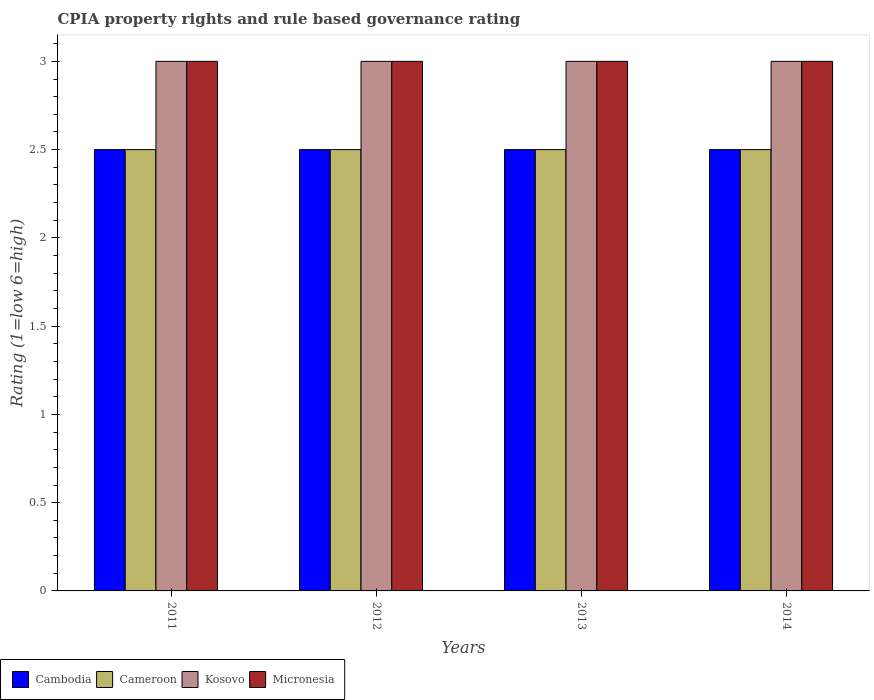How many different coloured bars are there?
Your response must be concise. 4. How many groups of bars are there?
Keep it short and to the point. 4. Are the number of bars on each tick of the X-axis equal?
Provide a short and direct response. Yes. What is the label of the 3rd group of bars from the left?
Keep it short and to the point. 2013. In how many cases, is the number of bars for a given year not equal to the number of legend labels?
Offer a terse response. 0. What is the CPIA rating in Cameroon in 2014?
Keep it short and to the point. 2.5. In which year was the CPIA rating in Cameroon minimum?
Your answer should be compact. 2011. What is the total CPIA rating in Cambodia in the graph?
Keep it short and to the point. 10. What is the difference between the CPIA rating in Cameroon in 2014 and the CPIA rating in Kosovo in 2013?
Ensure brevity in your answer.  -0.5. In how many years, is the CPIA rating in Kosovo greater than 1.4?
Offer a terse response. 4. What does the 2nd bar from the left in 2011 represents?
Provide a succinct answer. Cameroon. What does the 4th bar from the right in 2013 represents?
Provide a succinct answer. Cambodia. Is it the case that in every year, the sum of the CPIA rating in Micronesia and CPIA rating in Cameroon is greater than the CPIA rating in Kosovo?
Your answer should be very brief. Yes. How many bars are there?
Offer a very short reply. 16. Are all the bars in the graph horizontal?
Keep it short and to the point. No. How many years are there in the graph?
Provide a succinct answer. 4. What is the difference between two consecutive major ticks on the Y-axis?
Make the answer very short. 0.5. Does the graph contain any zero values?
Keep it short and to the point. No. How many legend labels are there?
Provide a succinct answer. 4. How are the legend labels stacked?
Provide a succinct answer. Horizontal. What is the title of the graph?
Make the answer very short. CPIA property rights and rule based governance rating. What is the label or title of the X-axis?
Keep it short and to the point. Years. What is the Rating (1=low 6=high) in Cambodia in 2011?
Your answer should be compact. 2.5. What is the Rating (1=low 6=high) in Kosovo in 2011?
Provide a succinct answer. 3. What is the Rating (1=low 6=high) of Kosovo in 2012?
Your answer should be very brief. 3. What is the Rating (1=low 6=high) in Micronesia in 2012?
Your response must be concise. 3. What is the Rating (1=low 6=high) in Cambodia in 2013?
Make the answer very short. 2.5. What is the Rating (1=low 6=high) of Cameroon in 2013?
Give a very brief answer. 2.5. What is the Rating (1=low 6=high) of Kosovo in 2013?
Make the answer very short. 3. What is the Rating (1=low 6=high) in Cameroon in 2014?
Offer a terse response. 2.5. What is the Rating (1=low 6=high) of Micronesia in 2014?
Your answer should be very brief. 3. Across all years, what is the minimum Rating (1=low 6=high) of Cameroon?
Offer a very short reply. 2.5. Across all years, what is the minimum Rating (1=low 6=high) in Kosovo?
Your answer should be very brief. 3. What is the total Rating (1=low 6=high) in Cambodia in the graph?
Your response must be concise. 10. What is the total Rating (1=low 6=high) of Kosovo in the graph?
Your response must be concise. 12. What is the difference between the Rating (1=low 6=high) of Cameroon in 2011 and that in 2012?
Your answer should be compact. 0. What is the difference between the Rating (1=low 6=high) of Cameroon in 2011 and that in 2013?
Provide a succinct answer. 0. What is the difference between the Rating (1=low 6=high) of Micronesia in 2011 and that in 2013?
Your answer should be very brief. 0. What is the difference between the Rating (1=low 6=high) in Kosovo in 2011 and that in 2014?
Give a very brief answer. 0. What is the difference between the Rating (1=low 6=high) in Micronesia in 2011 and that in 2014?
Your answer should be compact. 0. What is the difference between the Rating (1=low 6=high) in Cameroon in 2012 and that in 2013?
Keep it short and to the point. 0. What is the difference between the Rating (1=low 6=high) in Kosovo in 2012 and that in 2013?
Provide a succinct answer. 0. What is the difference between the Rating (1=low 6=high) of Cambodia in 2012 and that in 2014?
Offer a terse response. 0. What is the difference between the Rating (1=low 6=high) in Cameroon in 2012 and that in 2014?
Your response must be concise. 0. What is the difference between the Rating (1=low 6=high) of Kosovo in 2012 and that in 2014?
Provide a succinct answer. 0. What is the difference between the Rating (1=low 6=high) of Micronesia in 2012 and that in 2014?
Provide a succinct answer. 0. What is the difference between the Rating (1=low 6=high) of Kosovo in 2013 and that in 2014?
Make the answer very short. 0. What is the difference between the Rating (1=low 6=high) of Cambodia in 2011 and the Rating (1=low 6=high) of Cameroon in 2012?
Give a very brief answer. 0. What is the difference between the Rating (1=low 6=high) in Cambodia in 2011 and the Rating (1=low 6=high) in Kosovo in 2012?
Your response must be concise. -0.5. What is the difference between the Rating (1=low 6=high) in Cameroon in 2011 and the Rating (1=low 6=high) in Kosovo in 2012?
Your answer should be very brief. -0.5. What is the difference between the Rating (1=low 6=high) of Cameroon in 2011 and the Rating (1=low 6=high) of Micronesia in 2012?
Ensure brevity in your answer.  -0.5. What is the difference between the Rating (1=low 6=high) in Kosovo in 2011 and the Rating (1=low 6=high) in Micronesia in 2012?
Your response must be concise. 0. What is the difference between the Rating (1=low 6=high) of Cameroon in 2011 and the Rating (1=low 6=high) of Kosovo in 2013?
Offer a terse response. -0.5. What is the difference between the Rating (1=low 6=high) in Cameroon in 2011 and the Rating (1=low 6=high) in Micronesia in 2013?
Make the answer very short. -0.5. What is the difference between the Rating (1=low 6=high) in Cameroon in 2011 and the Rating (1=low 6=high) in Kosovo in 2014?
Offer a terse response. -0.5. What is the difference between the Rating (1=low 6=high) of Kosovo in 2011 and the Rating (1=low 6=high) of Micronesia in 2014?
Give a very brief answer. 0. What is the difference between the Rating (1=low 6=high) of Cambodia in 2012 and the Rating (1=low 6=high) of Kosovo in 2013?
Your answer should be very brief. -0.5. What is the difference between the Rating (1=low 6=high) of Cameroon in 2012 and the Rating (1=low 6=high) of Micronesia in 2013?
Make the answer very short. -0.5. What is the difference between the Rating (1=low 6=high) in Kosovo in 2012 and the Rating (1=low 6=high) in Micronesia in 2013?
Your response must be concise. 0. What is the difference between the Rating (1=low 6=high) of Cameroon in 2012 and the Rating (1=low 6=high) of Micronesia in 2014?
Make the answer very short. -0.5. What is the difference between the Rating (1=low 6=high) in Cambodia in 2013 and the Rating (1=low 6=high) in Cameroon in 2014?
Your answer should be compact. 0. What is the difference between the Rating (1=low 6=high) of Cameroon in 2013 and the Rating (1=low 6=high) of Kosovo in 2014?
Your response must be concise. -0.5. What is the difference between the Rating (1=low 6=high) in Cameroon in 2013 and the Rating (1=low 6=high) in Micronesia in 2014?
Your response must be concise. -0.5. What is the difference between the Rating (1=low 6=high) in Kosovo in 2013 and the Rating (1=low 6=high) in Micronesia in 2014?
Keep it short and to the point. 0. What is the average Rating (1=low 6=high) in Cameroon per year?
Your response must be concise. 2.5. In the year 2011, what is the difference between the Rating (1=low 6=high) in Cambodia and Rating (1=low 6=high) in Cameroon?
Your response must be concise. 0. In the year 2011, what is the difference between the Rating (1=low 6=high) of Cameroon and Rating (1=low 6=high) of Kosovo?
Offer a terse response. -0.5. In the year 2011, what is the difference between the Rating (1=low 6=high) of Kosovo and Rating (1=low 6=high) of Micronesia?
Give a very brief answer. 0. In the year 2012, what is the difference between the Rating (1=low 6=high) in Cambodia and Rating (1=low 6=high) in Cameroon?
Your answer should be compact. 0. In the year 2012, what is the difference between the Rating (1=low 6=high) in Cambodia and Rating (1=low 6=high) in Kosovo?
Offer a terse response. -0.5. In the year 2012, what is the difference between the Rating (1=low 6=high) in Cambodia and Rating (1=low 6=high) in Micronesia?
Make the answer very short. -0.5. In the year 2012, what is the difference between the Rating (1=low 6=high) in Cameroon and Rating (1=low 6=high) in Kosovo?
Your answer should be compact. -0.5. In the year 2012, what is the difference between the Rating (1=low 6=high) in Cameroon and Rating (1=low 6=high) in Micronesia?
Provide a short and direct response. -0.5. In the year 2012, what is the difference between the Rating (1=low 6=high) in Kosovo and Rating (1=low 6=high) in Micronesia?
Offer a very short reply. 0. In the year 2013, what is the difference between the Rating (1=low 6=high) in Cambodia and Rating (1=low 6=high) in Cameroon?
Your response must be concise. 0. In the year 2013, what is the difference between the Rating (1=low 6=high) of Cambodia and Rating (1=low 6=high) of Kosovo?
Provide a succinct answer. -0.5. In the year 2013, what is the difference between the Rating (1=low 6=high) in Cameroon and Rating (1=low 6=high) in Kosovo?
Provide a short and direct response. -0.5. In the year 2014, what is the difference between the Rating (1=low 6=high) of Cambodia and Rating (1=low 6=high) of Cameroon?
Keep it short and to the point. 0. In the year 2014, what is the difference between the Rating (1=low 6=high) of Cameroon and Rating (1=low 6=high) of Micronesia?
Provide a short and direct response. -0.5. What is the ratio of the Rating (1=low 6=high) in Cambodia in 2011 to that in 2012?
Your answer should be very brief. 1. What is the ratio of the Rating (1=low 6=high) in Micronesia in 2011 to that in 2012?
Your response must be concise. 1. What is the ratio of the Rating (1=low 6=high) in Cambodia in 2011 to that in 2013?
Keep it short and to the point. 1. What is the ratio of the Rating (1=low 6=high) of Cameroon in 2011 to that in 2013?
Your answer should be compact. 1. What is the ratio of the Rating (1=low 6=high) in Micronesia in 2011 to that in 2013?
Ensure brevity in your answer.  1. What is the ratio of the Rating (1=low 6=high) of Cambodia in 2011 to that in 2014?
Your answer should be compact. 1. What is the ratio of the Rating (1=low 6=high) of Cameroon in 2011 to that in 2014?
Make the answer very short. 1. What is the ratio of the Rating (1=low 6=high) of Kosovo in 2011 to that in 2014?
Give a very brief answer. 1. What is the ratio of the Rating (1=low 6=high) of Cambodia in 2012 to that in 2014?
Offer a terse response. 1. What is the ratio of the Rating (1=low 6=high) of Micronesia in 2012 to that in 2014?
Make the answer very short. 1. What is the ratio of the Rating (1=low 6=high) in Cameroon in 2013 to that in 2014?
Offer a very short reply. 1. What is the difference between the highest and the second highest Rating (1=low 6=high) in Cambodia?
Provide a succinct answer. 0. What is the difference between the highest and the second highest Rating (1=low 6=high) in Kosovo?
Offer a very short reply. 0. What is the difference between the highest and the second highest Rating (1=low 6=high) in Micronesia?
Make the answer very short. 0. What is the difference between the highest and the lowest Rating (1=low 6=high) in Cambodia?
Your answer should be compact. 0. 